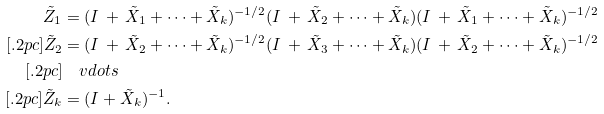<formula> <loc_0><loc_0><loc_500><loc_500>\tilde { Z } _ { 1 } & = ( I \, + \, \tilde { X } _ { 1 } + \cdots + \tilde { X } _ { k } ) ^ { - { { 1 } / { 2 } } } ( I \, + \, \tilde { X } _ { 2 } + \cdots + \tilde { X } _ { k } ) ( I \, + \, \tilde { X } _ { 1 } + \cdots + \tilde { X } _ { k } ) ^ { - { { 1 } / { 2 } } } \\ [ . 2 p c ] \tilde { Z } _ { 2 } & = ( I \, + \, \tilde { X } _ { 2 } + \cdots + \tilde { X } _ { k } ) ^ { - { { 1 } / { 2 } } } ( I \, + \, \tilde { X } _ { 3 } + \cdots + \tilde { X } _ { k } ) ( I \, + \, \tilde { X } _ { 2 } + \cdots + \tilde { X } _ { k } ) ^ { - { { 1 } / { 2 } } } \\ [ . 2 p c ] & \quad v d o t s \\ [ . 2 p c ] \tilde { Z } _ { k } & = ( I + \tilde { X } _ { k } ) ^ { - 1 } .</formula> 